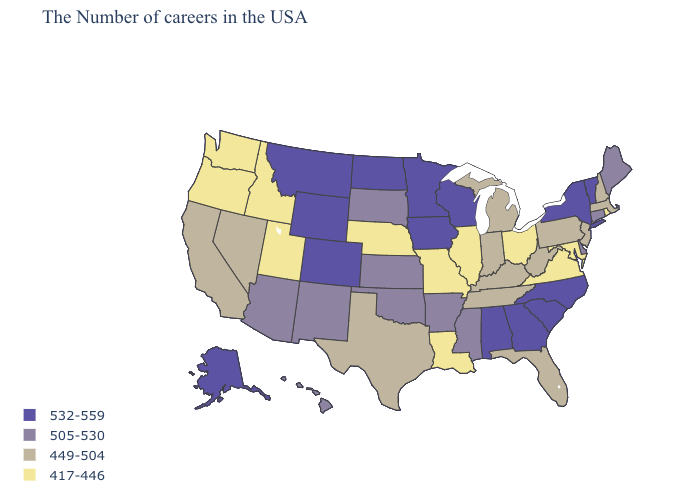Name the states that have a value in the range 532-559?
Short answer required. Vermont, New York, North Carolina, South Carolina, Georgia, Alabama, Wisconsin, Minnesota, Iowa, North Dakota, Wyoming, Colorado, Montana, Alaska. Does the map have missing data?
Answer briefly. No. Does Wyoming have the highest value in the USA?
Short answer required. Yes. What is the value of Michigan?
Answer briefly. 449-504. Name the states that have a value in the range 532-559?
Answer briefly. Vermont, New York, North Carolina, South Carolina, Georgia, Alabama, Wisconsin, Minnesota, Iowa, North Dakota, Wyoming, Colorado, Montana, Alaska. What is the highest value in the USA?
Concise answer only. 532-559. Name the states that have a value in the range 417-446?
Keep it brief. Rhode Island, Maryland, Virginia, Ohio, Illinois, Louisiana, Missouri, Nebraska, Utah, Idaho, Washington, Oregon. Name the states that have a value in the range 417-446?
Give a very brief answer. Rhode Island, Maryland, Virginia, Ohio, Illinois, Louisiana, Missouri, Nebraska, Utah, Idaho, Washington, Oregon. Name the states that have a value in the range 417-446?
Keep it brief. Rhode Island, Maryland, Virginia, Ohio, Illinois, Louisiana, Missouri, Nebraska, Utah, Idaho, Washington, Oregon. Among the states that border Pennsylvania , which have the highest value?
Keep it brief. New York. What is the value of Kentucky?
Give a very brief answer. 449-504. Name the states that have a value in the range 417-446?
Give a very brief answer. Rhode Island, Maryland, Virginia, Ohio, Illinois, Louisiana, Missouri, Nebraska, Utah, Idaho, Washington, Oregon. What is the lowest value in the USA?
Keep it brief. 417-446. Does New York have the lowest value in the USA?
Give a very brief answer. No. Among the states that border West Virginia , does Maryland have the highest value?
Be succinct. No. 